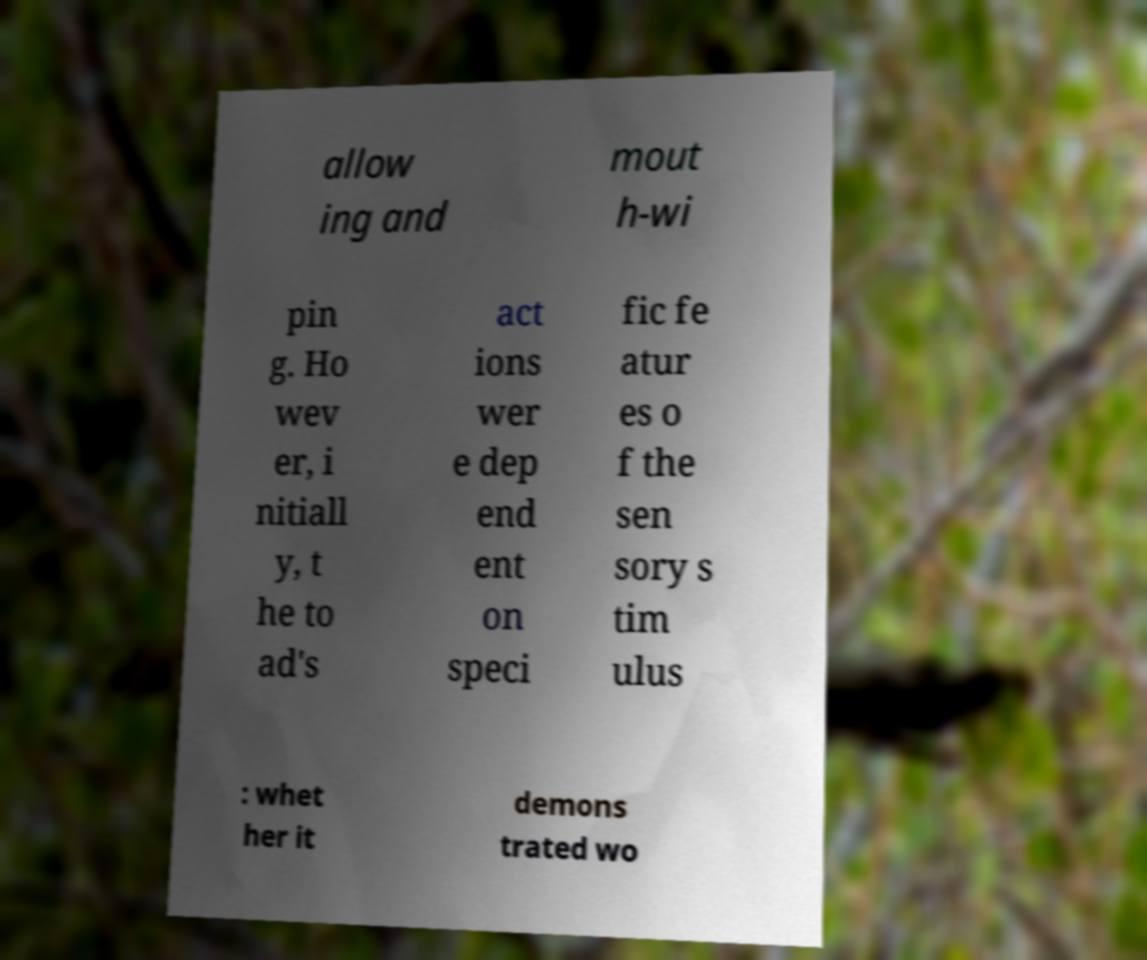Could you extract and type out the text from this image? allow ing and mout h-wi pin g. Ho wev er, i nitiall y, t he to ad's act ions wer e dep end ent on speci fic fe atur es o f the sen sory s tim ulus : whet her it demons trated wo 